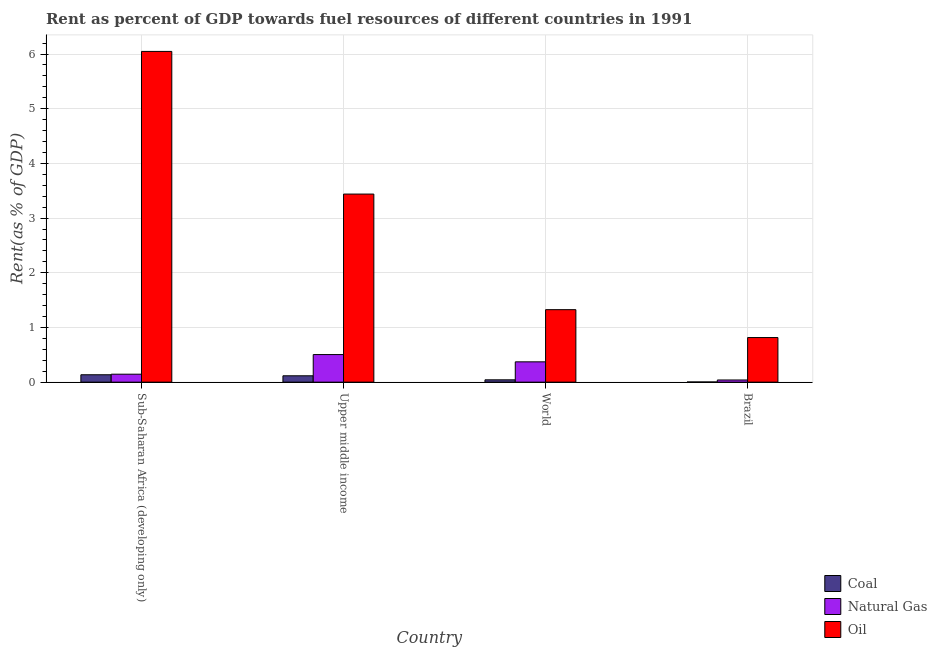How many different coloured bars are there?
Offer a very short reply. 3. How many groups of bars are there?
Offer a very short reply. 4. Are the number of bars per tick equal to the number of legend labels?
Provide a short and direct response. Yes. Are the number of bars on each tick of the X-axis equal?
Offer a terse response. Yes. How many bars are there on the 4th tick from the right?
Ensure brevity in your answer.  3. What is the label of the 1st group of bars from the left?
Your answer should be compact. Sub-Saharan Africa (developing only). In how many cases, is the number of bars for a given country not equal to the number of legend labels?
Provide a short and direct response. 0. What is the rent towards oil in Upper middle income?
Give a very brief answer. 3.44. Across all countries, what is the maximum rent towards coal?
Your answer should be compact. 0.14. Across all countries, what is the minimum rent towards oil?
Your answer should be very brief. 0.82. In which country was the rent towards natural gas maximum?
Your response must be concise. Upper middle income. In which country was the rent towards oil minimum?
Provide a succinct answer. Brazil. What is the total rent towards oil in the graph?
Make the answer very short. 11.63. What is the difference between the rent towards coal in Brazil and that in Sub-Saharan Africa (developing only)?
Ensure brevity in your answer.  -0.13. What is the difference between the rent towards natural gas in Upper middle income and the rent towards oil in Brazil?
Ensure brevity in your answer.  -0.31. What is the average rent towards oil per country?
Your answer should be very brief. 2.91. What is the difference between the rent towards coal and rent towards oil in World?
Make the answer very short. -1.28. In how many countries, is the rent towards coal greater than 2 %?
Offer a very short reply. 0. What is the ratio of the rent towards natural gas in Sub-Saharan Africa (developing only) to that in World?
Give a very brief answer. 0.39. What is the difference between the highest and the second highest rent towards oil?
Offer a very short reply. 2.61. What is the difference between the highest and the lowest rent towards oil?
Your answer should be compact. 5.23. In how many countries, is the rent towards coal greater than the average rent towards coal taken over all countries?
Provide a short and direct response. 2. What does the 3rd bar from the left in Sub-Saharan Africa (developing only) represents?
Provide a short and direct response. Oil. What does the 2nd bar from the right in World represents?
Keep it short and to the point. Natural Gas. How many bars are there?
Give a very brief answer. 12. How many countries are there in the graph?
Offer a terse response. 4. Are the values on the major ticks of Y-axis written in scientific E-notation?
Ensure brevity in your answer.  No. Does the graph contain any zero values?
Make the answer very short. No. How many legend labels are there?
Keep it short and to the point. 3. What is the title of the graph?
Your response must be concise. Rent as percent of GDP towards fuel resources of different countries in 1991. Does "Labor Tax" appear as one of the legend labels in the graph?
Provide a succinct answer. No. What is the label or title of the Y-axis?
Offer a terse response. Rent(as % of GDP). What is the Rent(as % of GDP) of Coal in Sub-Saharan Africa (developing only)?
Provide a succinct answer. 0.14. What is the Rent(as % of GDP) in Natural Gas in Sub-Saharan Africa (developing only)?
Offer a terse response. 0.15. What is the Rent(as % of GDP) in Oil in Sub-Saharan Africa (developing only)?
Provide a short and direct response. 6.05. What is the Rent(as % of GDP) in Coal in Upper middle income?
Give a very brief answer. 0.12. What is the Rent(as % of GDP) of Natural Gas in Upper middle income?
Keep it short and to the point. 0.5. What is the Rent(as % of GDP) in Oil in Upper middle income?
Your response must be concise. 3.44. What is the Rent(as % of GDP) of Coal in World?
Give a very brief answer. 0.04. What is the Rent(as % of GDP) in Natural Gas in World?
Your response must be concise. 0.37. What is the Rent(as % of GDP) of Oil in World?
Your answer should be very brief. 1.33. What is the Rent(as % of GDP) of Coal in Brazil?
Ensure brevity in your answer.  0. What is the Rent(as % of GDP) of Natural Gas in Brazil?
Keep it short and to the point. 0.04. What is the Rent(as % of GDP) in Oil in Brazil?
Your response must be concise. 0.82. Across all countries, what is the maximum Rent(as % of GDP) of Coal?
Offer a terse response. 0.14. Across all countries, what is the maximum Rent(as % of GDP) in Natural Gas?
Provide a succinct answer. 0.5. Across all countries, what is the maximum Rent(as % of GDP) of Oil?
Give a very brief answer. 6.05. Across all countries, what is the minimum Rent(as % of GDP) of Coal?
Offer a terse response. 0. Across all countries, what is the minimum Rent(as % of GDP) in Natural Gas?
Your answer should be compact. 0.04. Across all countries, what is the minimum Rent(as % of GDP) of Oil?
Give a very brief answer. 0.82. What is the total Rent(as % of GDP) of Coal in the graph?
Provide a succinct answer. 0.3. What is the total Rent(as % of GDP) of Natural Gas in the graph?
Offer a very short reply. 1.06. What is the total Rent(as % of GDP) of Oil in the graph?
Offer a terse response. 11.63. What is the difference between the Rent(as % of GDP) in Coal in Sub-Saharan Africa (developing only) and that in Upper middle income?
Offer a terse response. 0.02. What is the difference between the Rent(as % of GDP) of Natural Gas in Sub-Saharan Africa (developing only) and that in Upper middle income?
Your answer should be compact. -0.36. What is the difference between the Rent(as % of GDP) in Oil in Sub-Saharan Africa (developing only) and that in Upper middle income?
Give a very brief answer. 2.61. What is the difference between the Rent(as % of GDP) in Coal in Sub-Saharan Africa (developing only) and that in World?
Give a very brief answer. 0.09. What is the difference between the Rent(as % of GDP) of Natural Gas in Sub-Saharan Africa (developing only) and that in World?
Make the answer very short. -0.23. What is the difference between the Rent(as % of GDP) of Oil in Sub-Saharan Africa (developing only) and that in World?
Give a very brief answer. 4.72. What is the difference between the Rent(as % of GDP) of Coal in Sub-Saharan Africa (developing only) and that in Brazil?
Provide a succinct answer. 0.13. What is the difference between the Rent(as % of GDP) in Natural Gas in Sub-Saharan Africa (developing only) and that in Brazil?
Your answer should be compact. 0.11. What is the difference between the Rent(as % of GDP) of Oil in Sub-Saharan Africa (developing only) and that in Brazil?
Offer a terse response. 5.23. What is the difference between the Rent(as % of GDP) of Coal in Upper middle income and that in World?
Your response must be concise. 0.07. What is the difference between the Rent(as % of GDP) of Natural Gas in Upper middle income and that in World?
Your answer should be very brief. 0.13. What is the difference between the Rent(as % of GDP) of Oil in Upper middle income and that in World?
Keep it short and to the point. 2.11. What is the difference between the Rent(as % of GDP) of Coal in Upper middle income and that in Brazil?
Offer a terse response. 0.11. What is the difference between the Rent(as % of GDP) in Natural Gas in Upper middle income and that in Brazil?
Provide a short and direct response. 0.46. What is the difference between the Rent(as % of GDP) of Oil in Upper middle income and that in Brazil?
Provide a short and direct response. 2.62. What is the difference between the Rent(as % of GDP) in Coal in World and that in Brazil?
Provide a short and direct response. 0.04. What is the difference between the Rent(as % of GDP) of Natural Gas in World and that in Brazil?
Offer a terse response. 0.33. What is the difference between the Rent(as % of GDP) of Oil in World and that in Brazil?
Give a very brief answer. 0.51. What is the difference between the Rent(as % of GDP) in Coal in Sub-Saharan Africa (developing only) and the Rent(as % of GDP) in Natural Gas in Upper middle income?
Your answer should be very brief. -0.37. What is the difference between the Rent(as % of GDP) in Coal in Sub-Saharan Africa (developing only) and the Rent(as % of GDP) in Oil in Upper middle income?
Provide a succinct answer. -3.3. What is the difference between the Rent(as % of GDP) in Natural Gas in Sub-Saharan Africa (developing only) and the Rent(as % of GDP) in Oil in Upper middle income?
Provide a short and direct response. -3.29. What is the difference between the Rent(as % of GDP) of Coal in Sub-Saharan Africa (developing only) and the Rent(as % of GDP) of Natural Gas in World?
Your response must be concise. -0.24. What is the difference between the Rent(as % of GDP) of Coal in Sub-Saharan Africa (developing only) and the Rent(as % of GDP) of Oil in World?
Make the answer very short. -1.19. What is the difference between the Rent(as % of GDP) in Natural Gas in Sub-Saharan Africa (developing only) and the Rent(as % of GDP) in Oil in World?
Offer a very short reply. -1.18. What is the difference between the Rent(as % of GDP) in Coal in Sub-Saharan Africa (developing only) and the Rent(as % of GDP) in Natural Gas in Brazil?
Your answer should be compact. 0.1. What is the difference between the Rent(as % of GDP) in Coal in Sub-Saharan Africa (developing only) and the Rent(as % of GDP) in Oil in Brazil?
Offer a terse response. -0.68. What is the difference between the Rent(as % of GDP) of Natural Gas in Sub-Saharan Africa (developing only) and the Rent(as % of GDP) of Oil in Brazil?
Keep it short and to the point. -0.67. What is the difference between the Rent(as % of GDP) in Coal in Upper middle income and the Rent(as % of GDP) in Natural Gas in World?
Give a very brief answer. -0.26. What is the difference between the Rent(as % of GDP) in Coal in Upper middle income and the Rent(as % of GDP) in Oil in World?
Your answer should be very brief. -1.21. What is the difference between the Rent(as % of GDP) in Natural Gas in Upper middle income and the Rent(as % of GDP) in Oil in World?
Give a very brief answer. -0.82. What is the difference between the Rent(as % of GDP) of Coal in Upper middle income and the Rent(as % of GDP) of Natural Gas in Brazil?
Make the answer very short. 0.08. What is the difference between the Rent(as % of GDP) in Coal in Upper middle income and the Rent(as % of GDP) in Oil in Brazil?
Give a very brief answer. -0.7. What is the difference between the Rent(as % of GDP) of Natural Gas in Upper middle income and the Rent(as % of GDP) of Oil in Brazil?
Offer a terse response. -0.31. What is the difference between the Rent(as % of GDP) of Coal in World and the Rent(as % of GDP) of Natural Gas in Brazil?
Offer a terse response. 0. What is the difference between the Rent(as % of GDP) in Coal in World and the Rent(as % of GDP) in Oil in Brazil?
Your answer should be very brief. -0.77. What is the difference between the Rent(as % of GDP) of Natural Gas in World and the Rent(as % of GDP) of Oil in Brazil?
Make the answer very short. -0.44. What is the average Rent(as % of GDP) of Coal per country?
Your answer should be very brief. 0.07. What is the average Rent(as % of GDP) of Natural Gas per country?
Your answer should be compact. 0.27. What is the average Rent(as % of GDP) of Oil per country?
Your answer should be compact. 2.91. What is the difference between the Rent(as % of GDP) in Coal and Rent(as % of GDP) in Natural Gas in Sub-Saharan Africa (developing only)?
Give a very brief answer. -0.01. What is the difference between the Rent(as % of GDP) in Coal and Rent(as % of GDP) in Oil in Sub-Saharan Africa (developing only)?
Ensure brevity in your answer.  -5.91. What is the difference between the Rent(as % of GDP) of Natural Gas and Rent(as % of GDP) of Oil in Sub-Saharan Africa (developing only)?
Provide a short and direct response. -5.9. What is the difference between the Rent(as % of GDP) of Coal and Rent(as % of GDP) of Natural Gas in Upper middle income?
Keep it short and to the point. -0.39. What is the difference between the Rent(as % of GDP) in Coal and Rent(as % of GDP) in Oil in Upper middle income?
Keep it short and to the point. -3.32. What is the difference between the Rent(as % of GDP) in Natural Gas and Rent(as % of GDP) in Oil in Upper middle income?
Provide a succinct answer. -2.93. What is the difference between the Rent(as % of GDP) in Coal and Rent(as % of GDP) in Natural Gas in World?
Your answer should be very brief. -0.33. What is the difference between the Rent(as % of GDP) in Coal and Rent(as % of GDP) in Oil in World?
Provide a short and direct response. -1.28. What is the difference between the Rent(as % of GDP) in Natural Gas and Rent(as % of GDP) in Oil in World?
Provide a succinct answer. -0.95. What is the difference between the Rent(as % of GDP) of Coal and Rent(as % of GDP) of Natural Gas in Brazil?
Keep it short and to the point. -0.04. What is the difference between the Rent(as % of GDP) of Coal and Rent(as % of GDP) of Oil in Brazil?
Provide a succinct answer. -0.81. What is the difference between the Rent(as % of GDP) of Natural Gas and Rent(as % of GDP) of Oil in Brazil?
Offer a terse response. -0.78. What is the ratio of the Rent(as % of GDP) in Coal in Sub-Saharan Africa (developing only) to that in Upper middle income?
Your answer should be very brief. 1.16. What is the ratio of the Rent(as % of GDP) in Natural Gas in Sub-Saharan Africa (developing only) to that in Upper middle income?
Give a very brief answer. 0.29. What is the ratio of the Rent(as % of GDP) in Oil in Sub-Saharan Africa (developing only) to that in Upper middle income?
Make the answer very short. 1.76. What is the ratio of the Rent(as % of GDP) of Coal in Sub-Saharan Africa (developing only) to that in World?
Ensure brevity in your answer.  3.18. What is the ratio of the Rent(as % of GDP) in Natural Gas in Sub-Saharan Africa (developing only) to that in World?
Offer a very short reply. 0.39. What is the ratio of the Rent(as % of GDP) of Oil in Sub-Saharan Africa (developing only) to that in World?
Keep it short and to the point. 4.56. What is the ratio of the Rent(as % of GDP) in Coal in Sub-Saharan Africa (developing only) to that in Brazil?
Provide a short and direct response. 43.89. What is the ratio of the Rent(as % of GDP) of Natural Gas in Sub-Saharan Africa (developing only) to that in Brazil?
Make the answer very short. 3.67. What is the ratio of the Rent(as % of GDP) in Oil in Sub-Saharan Africa (developing only) to that in Brazil?
Your answer should be very brief. 7.42. What is the ratio of the Rent(as % of GDP) of Coal in Upper middle income to that in World?
Provide a succinct answer. 2.73. What is the ratio of the Rent(as % of GDP) in Natural Gas in Upper middle income to that in World?
Your answer should be very brief. 1.36. What is the ratio of the Rent(as % of GDP) of Oil in Upper middle income to that in World?
Offer a very short reply. 2.59. What is the ratio of the Rent(as % of GDP) of Coal in Upper middle income to that in Brazil?
Ensure brevity in your answer.  37.72. What is the ratio of the Rent(as % of GDP) of Natural Gas in Upper middle income to that in Brazil?
Offer a terse response. 12.74. What is the ratio of the Rent(as % of GDP) of Oil in Upper middle income to that in Brazil?
Offer a terse response. 4.22. What is the ratio of the Rent(as % of GDP) of Coal in World to that in Brazil?
Give a very brief answer. 13.8. What is the ratio of the Rent(as % of GDP) of Natural Gas in World to that in Brazil?
Your answer should be compact. 9.38. What is the ratio of the Rent(as % of GDP) of Oil in World to that in Brazil?
Provide a succinct answer. 1.63. What is the difference between the highest and the second highest Rent(as % of GDP) of Coal?
Your answer should be very brief. 0.02. What is the difference between the highest and the second highest Rent(as % of GDP) in Natural Gas?
Make the answer very short. 0.13. What is the difference between the highest and the second highest Rent(as % of GDP) of Oil?
Your answer should be compact. 2.61. What is the difference between the highest and the lowest Rent(as % of GDP) in Coal?
Make the answer very short. 0.13. What is the difference between the highest and the lowest Rent(as % of GDP) in Natural Gas?
Provide a short and direct response. 0.46. What is the difference between the highest and the lowest Rent(as % of GDP) of Oil?
Provide a short and direct response. 5.23. 